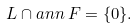Convert formula to latex. <formula><loc_0><loc_0><loc_500><loc_500>L \cap a n n \, F = \{ 0 \} .</formula> 